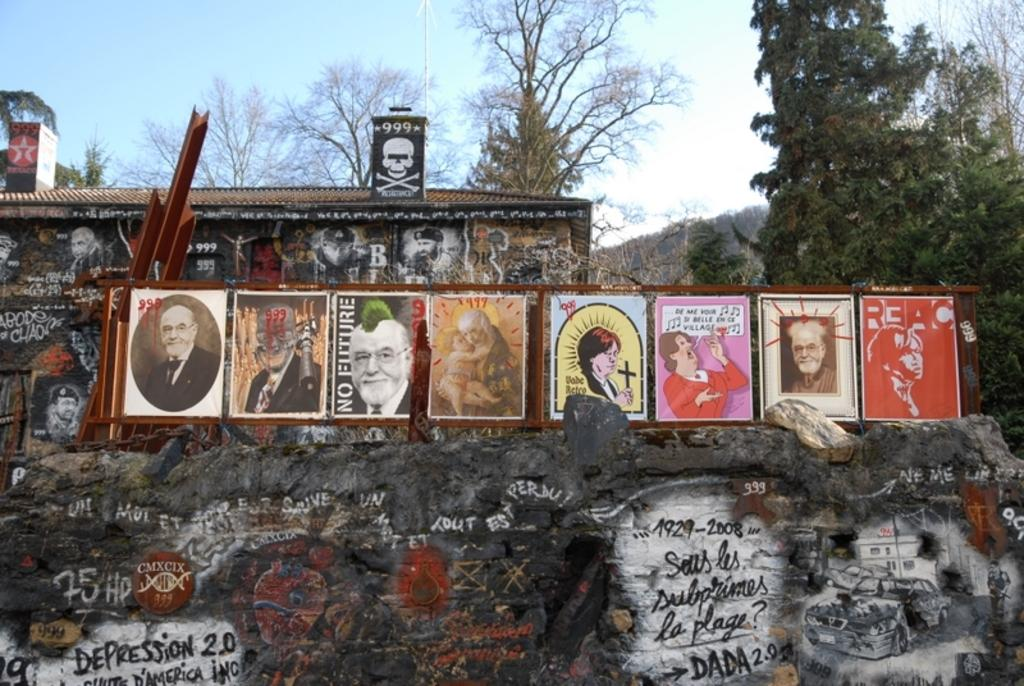What is present on the wall in the image? There are paintings on the wall in the image. What other objects can be seen in the image? There are boards and a shed in the background of the image. What type of vegetation is visible in the background of the image? There are trees in the background of the image. What is visible at the top of the image? The sky is visible at the top of the image. Can you tell me how many hats are hanging on the trees in the image? There are no hats present in the image; it only features a wall with paintings, boards, a shed, trees, and the sky. 